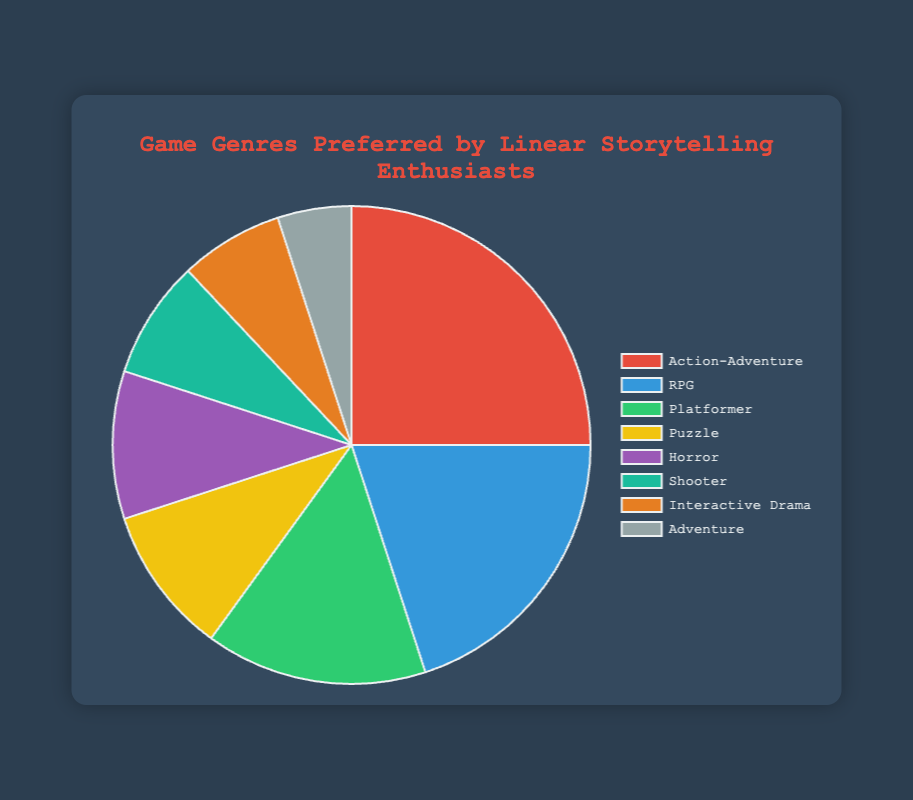What is the most preferred game genre among players who enjoy linear storytelling? The slice representing Action-Adventure is the largest in the pie chart. By looking at the size, we can see that it occupies the most significant percentage.
Answer: Action-Adventure Which two game genres together account for 40% of the preferences? The percentages of RPG (20%) and Platformer (15%) add up to 35%, and if we include Puzzle (10%), it exceeds 40%. However, Action-Adventure (25%) and RPG (20%) together add up to exactly 45%. Therefore, Action-Adventure (25%) and RPG (20%) together sum up to 45%.
Answer: Action-Adventure and RPG How much more popular is the Action-Adventure genre compared to the Interactive Drama genre? Action-Adventure accounts for 25% while Interactive Drama accounts for 7%. The difference in their percentages is 25% - 7% = 18%.
Answer: 18% What percentage of players prefer Horror or Puzzle games? The percentage for Horror is 10% and Puzzle is also 10%. Adding them together, we get 10% + 10% = 20%.
Answer: 20% Which genre is least preferred by players who enjoy linear storytelling? The smallest slice in the pie chart represents the Adventure genre, which is the least preferred with 5%.
Answer: Adventure If we combine the percentages of Shooter and Interactive Drama genres, what is the resulting percentage? Shooter accounts for 8% and Interactive Drama for 7%. Summing these percentages gives 8% + 7% = 15%.
Answer: 15% Compare the preferences for Platformer and Adventure genres. How much more preferred is Platformer compared to Adventure? Platformer has a percentage of 15% while Adventure has 5%. The difference between them is 15% - 5% = 10%.
Answer: 10% Which genre's slice is represented by the green color in the pie chart? The green-colored slice is associated with Platformer.
Answer: Platformer If you look at the pie chart, which color represents RPG (Role-Playing Game)? The segment for RPG is depicted in blue color in the pie chart.
Answer: Blue What's the sum of percentages for genres with more than 10% preference each? The genres with more than 10% are Action-Adventure (25%), RPG (20%), and Platformer (15%). Adding them gives 25% + 20% + 15% = 60%.
Answer: 60% 